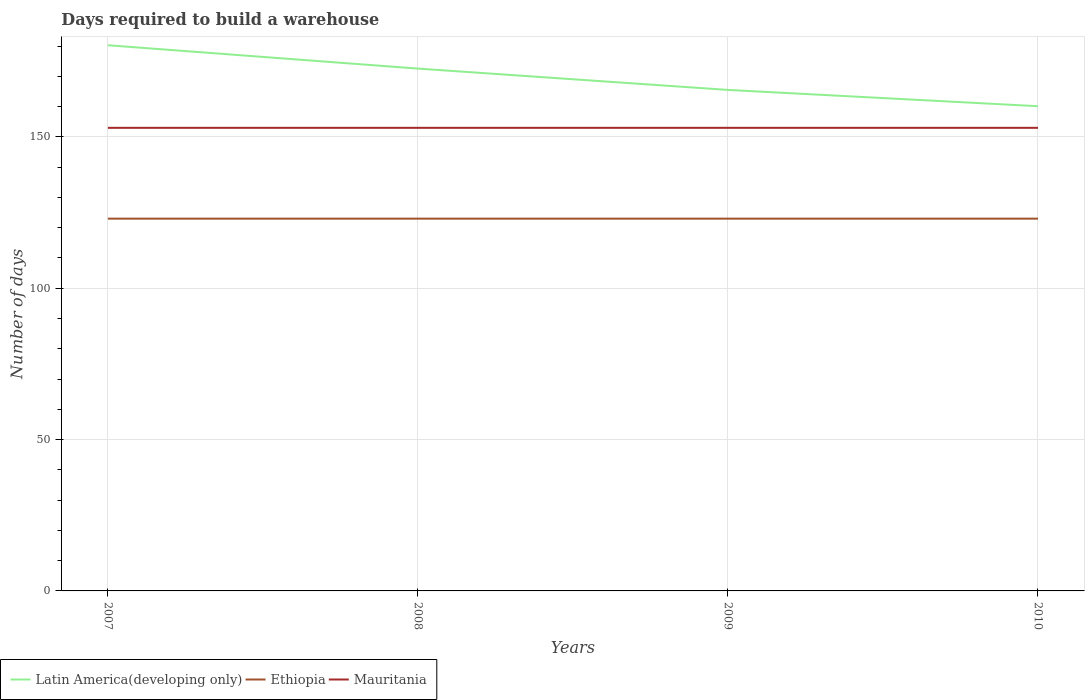How many different coloured lines are there?
Give a very brief answer. 3. Is the number of lines equal to the number of legend labels?
Offer a terse response. Yes. Across all years, what is the maximum days required to build a warehouse in in Ethiopia?
Your answer should be compact. 123. In which year was the days required to build a warehouse in in Ethiopia maximum?
Your response must be concise. 2007. What is the total days required to build a warehouse in in Ethiopia in the graph?
Offer a terse response. 0. What is the difference between the highest and the second highest days required to build a warehouse in in Latin America(developing only)?
Keep it short and to the point. 20.14. What is the difference between the highest and the lowest days required to build a warehouse in in Ethiopia?
Keep it short and to the point. 0. How many lines are there?
Ensure brevity in your answer.  3. What is the difference between two consecutive major ticks on the Y-axis?
Your answer should be compact. 50. Are the values on the major ticks of Y-axis written in scientific E-notation?
Offer a very short reply. No. Where does the legend appear in the graph?
Provide a succinct answer. Bottom left. How are the legend labels stacked?
Give a very brief answer. Horizontal. What is the title of the graph?
Provide a short and direct response. Days required to build a warehouse. What is the label or title of the Y-axis?
Keep it short and to the point. Number of days. What is the Number of days of Latin America(developing only) in 2007?
Ensure brevity in your answer.  180.29. What is the Number of days in Ethiopia in 2007?
Offer a terse response. 123. What is the Number of days in Mauritania in 2007?
Give a very brief answer. 153. What is the Number of days in Latin America(developing only) in 2008?
Make the answer very short. 172.57. What is the Number of days of Ethiopia in 2008?
Offer a terse response. 123. What is the Number of days of Mauritania in 2008?
Give a very brief answer. 153. What is the Number of days in Latin America(developing only) in 2009?
Offer a very short reply. 165.52. What is the Number of days of Ethiopia in 2009?
Provide a short and direct response. 123. What is the Number of days of Mauritania in 2009?
Keep it short and to the point. 153. What is the Number of days of Latin America(developing only) in 2010?
Make the answer very short. 160.14. What is the Number of days of Ethiopia in 2010?
Your answer should be very brief. 123. What is the Number of days in Mauritania in 2010?
Offer a terse response. 153. Across all years, what is the maximum Number of days in Latin America(developing only)?
Provide a succinct answer. 180.29. Across all years, what is the maximum Number of days of Ethiopia?
Make the answer very short. 123. Across all years, what is the maximum Number of days in Mauritania?
Your response must be concise. 153. Across all years, what is the minimum Number of days in Latin America(developing only)?
Ensure brevity in your answer.  160.14. Across all years, what is the minimum Number of days of Ethiopia?
Offer a terse response. 123. Across all years, what is the minimum Number of days in Mauritania?
Offer a terse response. 153. What is the total Number of days of Latin America(developing only) in the graph?
Ensure brevity in your answer.  678.52. What is the total Number of days in Ethiopia in the graph?
Offer a terse response. 492. What is the total Number of days of Mauritania in the graph?
Make the answer very short. 612. What is the difference between the Number of days in Latin America(developing only) in 2007 and that in 2008?
Your answer should be very brief. 7.71. What is the difference between the Number of days of Latin America(developing only) in 2007 and that in 2009?
Provide a succinct answer. 14.76. What is the difference between the Number of days in Latin America(developing only) in 2007 and that in 2010?
Offer a terse response. 20.14. What is the difference between the Number of days in Ethiopia in 2007 and that in 2010?
Offer a very short reply. 0. What is the difference between the Number of days in Latin America(developing only) in 2008 and that in 2009?
Give a very brief answer. 7.05. What is the difference between the Number of days in Ethiopia in 2008 and that in 2009?
Make the answer very short. 0. What is the difference between the Number of days in Latin America(developing only) in 2008 and that in 2010?
Provide a succinct answer. 12.43. What is the difference between the Number of days in Mauritania in 2008 and that in 2010?
Your answer should be compact. 0. What is the difference between the Number of days of Latin America(developing only) in 2009 and that in 2010?
Provide a succinct answer. 5.38. What is the difference between the Number of days in Ethiopia in 2009 and that in 2010?
Provide a short and direct response. 0. What is the difference between the Number of days in Mauritania in 2009 and that in 2010?
Offer a very short reply. 0. What is the difference between the Number of days of Latin America(developing only) in 2007 and the Number of days of Ethiopia in 2008?
Give a very brief answer. 57.29. What is the difference between the Number of days in Latin America(developing only) in 2007 and the Number of days in Mauritania in 2008?
Give a very brief answer. 27.29. What is the difference between the Number of days in Ethiopia in 2007 and the Number of days in Mauritania in 2008?
Your response must be concise. -30. What is the difference between the Number of days in Latin America(developing only) in 2007 and the Number of days in Ethiopia in 2009?
Make the answer very short. 57.29. What is the difference between the Number of days in Latin America(developing only) in 2007 and the Number of days in Mauritania in 2009?
Provide a succinct answer. 27.29. What is the difference between the Number of days in Latin America(developing only) in 2007 and the Number of days in Ethiopia in 2010?
Provide a succinct answer. 57.29. What is the difference between the Number of days in Latin America(developing only) in 2007 and the Number of days in Mauritania in 2010?
Ensure brevity in your answer.  27.29. What is the difference between the Number of days in Latin America(developing only) in 2008 and the Number of days in Ethiopia in 2009?
Offer a very short reply. 49.57. What is the difference between the Number of days in Latin America(developing only) in 2008 and the Number of days in Mauritania in 2009?
Give a very brief answer. 19.57. What is the difference between the Number of days in Latin America(developing only) in 2008 and the Number of days in Ethiopia in 2010?
Offer a very short reply. 49.57. What is the difference between the Number of days of Latin America(developing only) in 2008 and the Number of days of Mauritania in 2010?
Give a very brief answer. 19.57. What is the difference between the Number of days in Latin America(developing only) in 2009 and the Number of days in Ethiopia in 2010?
Offer a very short reply. 42.52. What is the difference between the Number of days of Latin America(developing only) in 2009 and the Number of days of Mauritania in 2010?
Provide a short and direct response. 12.52. What is the difference between the Number of days of Ethiopia in 2009 and the Number of days of Mauritania in 2010?
Ensure brevity in your answer.  -30. What is the average Number of days in Latin America(developing only) per year?
Offer a very short reply. 169.63. What is the average Number of days in Ethiopia per year?
Provide a succinct answer. 123. What is the average Number of days of Mauritania per year?
Your answer should be very brief. 153. In the year 2007, what is the difference between the Number of days in Latin America(developing only) and Number of days in Ethiopia?
Ensure brevity in your answer.  57.29. In the year 2007, what is the difference between the Number of days in Latin America(developing only) and Number of days in Mauritania?
Ensure brevity in your answer.  27.29. In the year 2008, what is the difference between the Number of days of Latin America(developing only) and Number of days of Ethiopia?
Keep it short and to the point. 49.57. In the year 2008, what is the difference between the Number of days of Latin America(developing only) and Number of days of Mauritania?
Provide a succinct answer. 19.57. In the year 2009, what is the difference between the Number of days in Latin America(developing only) and Number of days in Ethiopia?
Your answer should be compact. 42.52. In the year 2009, what is the difference between the Number of days in Latin America(developing only) and Number of days in Mauritania?
Offer a very short reply. 12.52. In the year 2009, what is the difference between the Number of days in Ethiopia and Number of days in Mauritania?
Your answer should be very brief. -30. In the year 2010, what is the difference between the Number of days of Latin America(developing only) and Number of days of Ethiopia?
Make the answer very short. 37.14. In the year 2010, what is the difference between the Number of days in Latin America(developing only) and Number of days in Mauritania?
Make the answer very short. 7.14. In the year 2010, what is the difference between the Number of days in Ethiopia and Number of days in Mauritania?
Provide a succinct answer. -30. What is the ratio of the Number of days of Latin America(developing only) in 2007 to that in 2008?
Ensure brevity in your answer.  1.04. What is the ratio of the Number of days of Ethiopia in 2007 to that in 2008?
Give a very brief answer. 1. What is the ratio of the Number of days of Latin America(developing only) in 2007 to that in 2009?
Your answer should be very brief. 1.09. What is the ratio of the Number of days of Latin America(developing only) in 2007 to that in 2010?
Ensure brevity in your answer.  1.13. What is the ratio of the Number of days of Ethiopia in 2007 to that in 2010?
Ensure brevity in your answer.  1. What is the ratio of the Number of days of Mauritania in 2007 to that in 2010?
Provide a succinct answer. 1. What is the ratio of the Number of days in Latin America(developing only) in 2008 to that in 2009?
Provide a short and direct response. 1.04. What is the ratio of the Number of days of Latin America(developing only) in 2008 to that in 2010?
Your answer should be compact. 1.08. What is the ratio of the Number of days of Mauritania in 2008 to that in 2010?
Your answer should be compact. 1. What is the ratio of the Number of days of Latin America(developing only) in 2009 to that in 2010?
Offer a very short reply. 1.03. What is the ratio of the Number of days in Mauritania in 2009 to that in 2010?
Ensure brevity in your answer.  1. What is the difference between the highest and the second highest Number of days of Latin America(developing only)?
Keep it short and to the point. 7.71. What is the difference between the highest and the second highest Number of days in Mauritania?
Give a very brief answer. 0. What is the difference between the highest and the lowest Number of days in Latin America(developing only)?
Offer a terse response. 20.14. What is the difference between the highest and the lowest Number of days in Mauritania?
Make the answer very short. 0. 